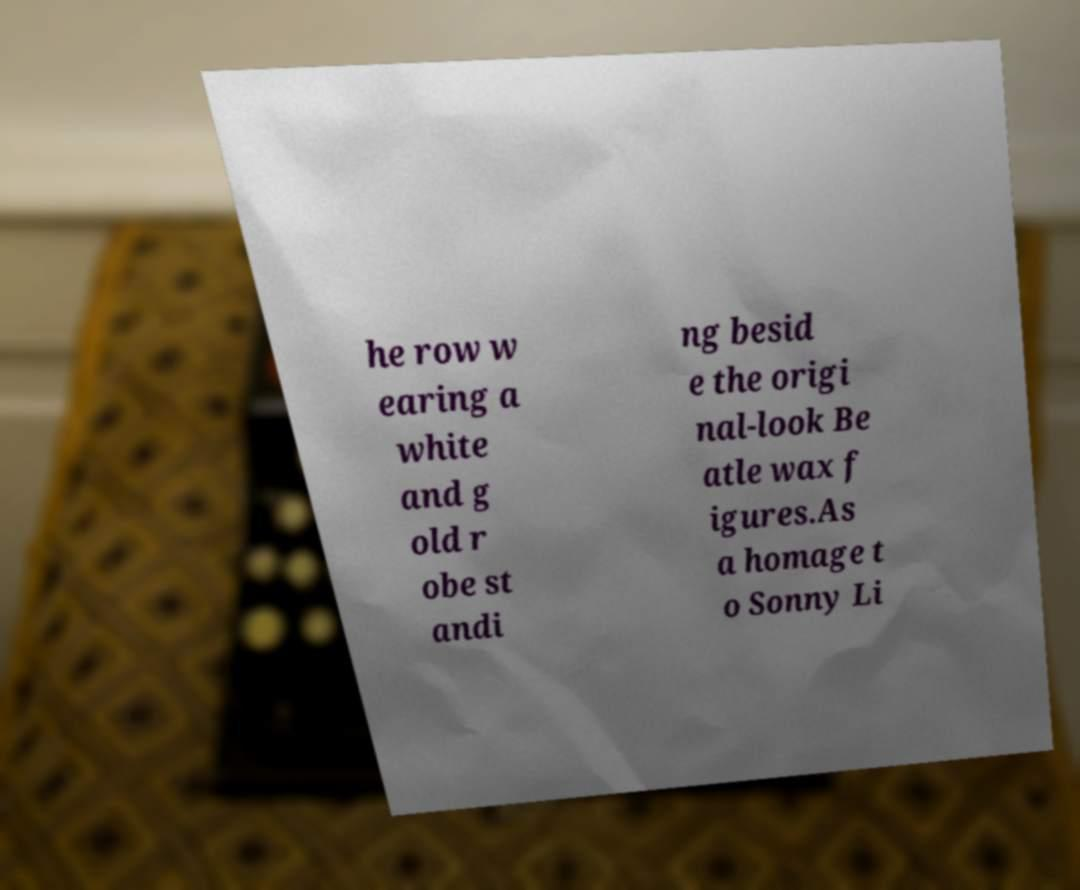Please read and relay the text visible in this image. What does it say? he row w earing a white and g old r obe st andi ng besid e the origi nal-look Be atle wax f igures.As a homage t o Sonny Li 